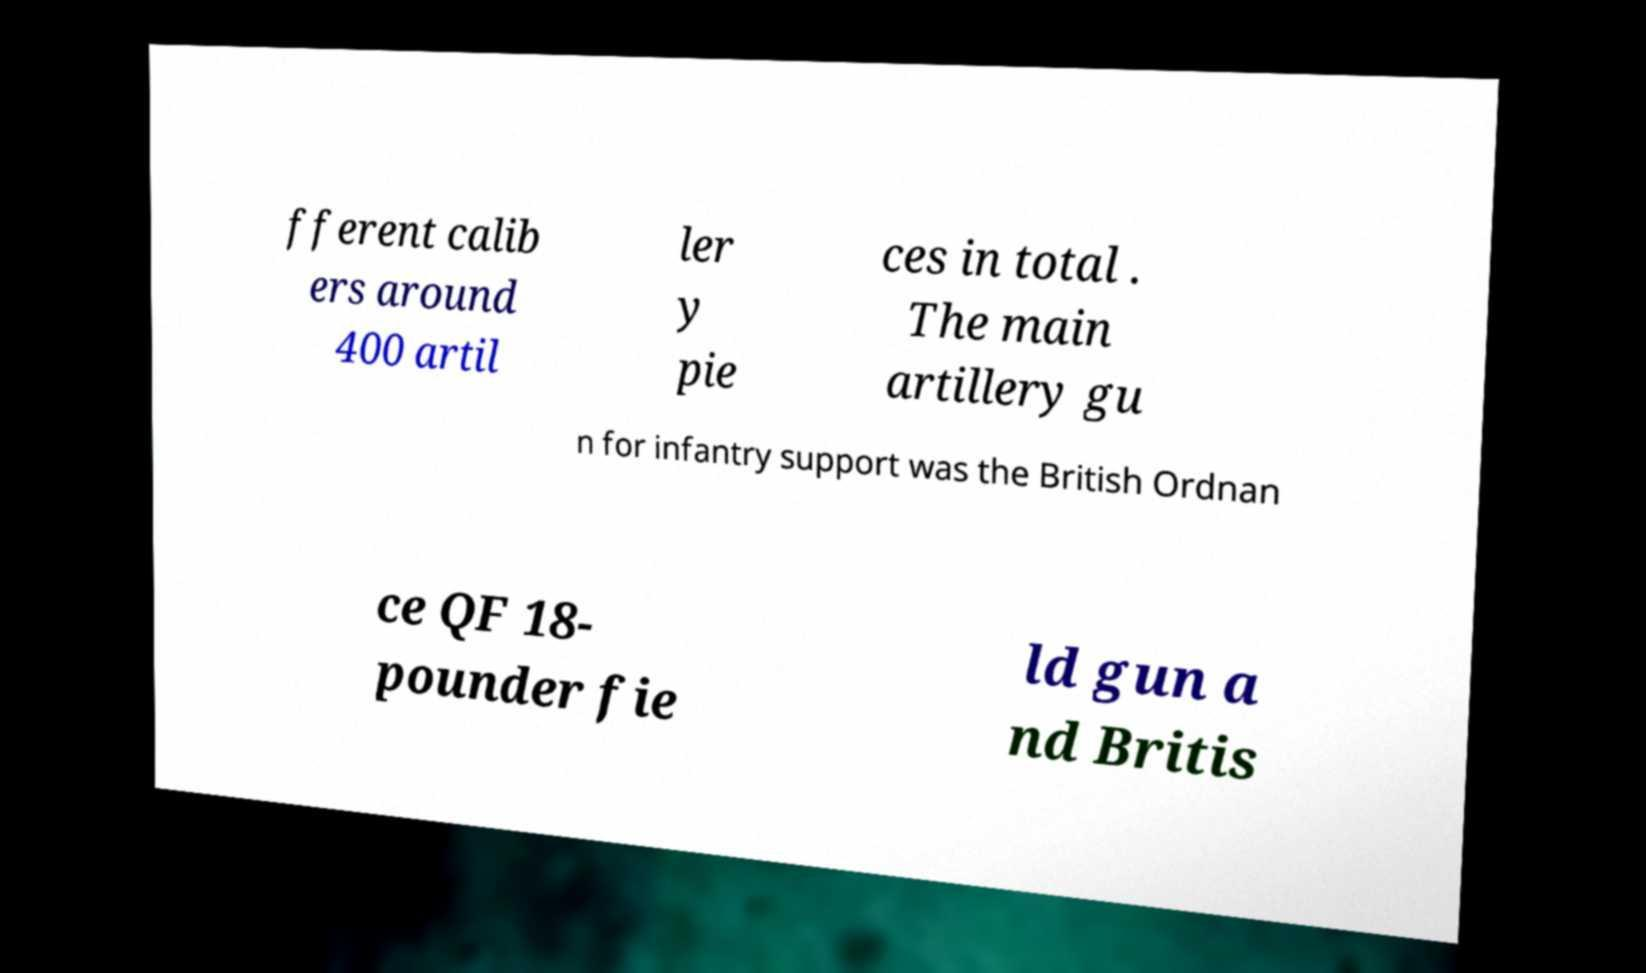Can you read and provide the text displayed in the image?This photo seems to have some interesting text. Can you extract and type it out for me? fferent calib ers around 400 artil ler y pie ces in total . The main artillery gu n for infantry support was the British Ordnan ce QF 18- pounder fie ld gun a nd Britis 